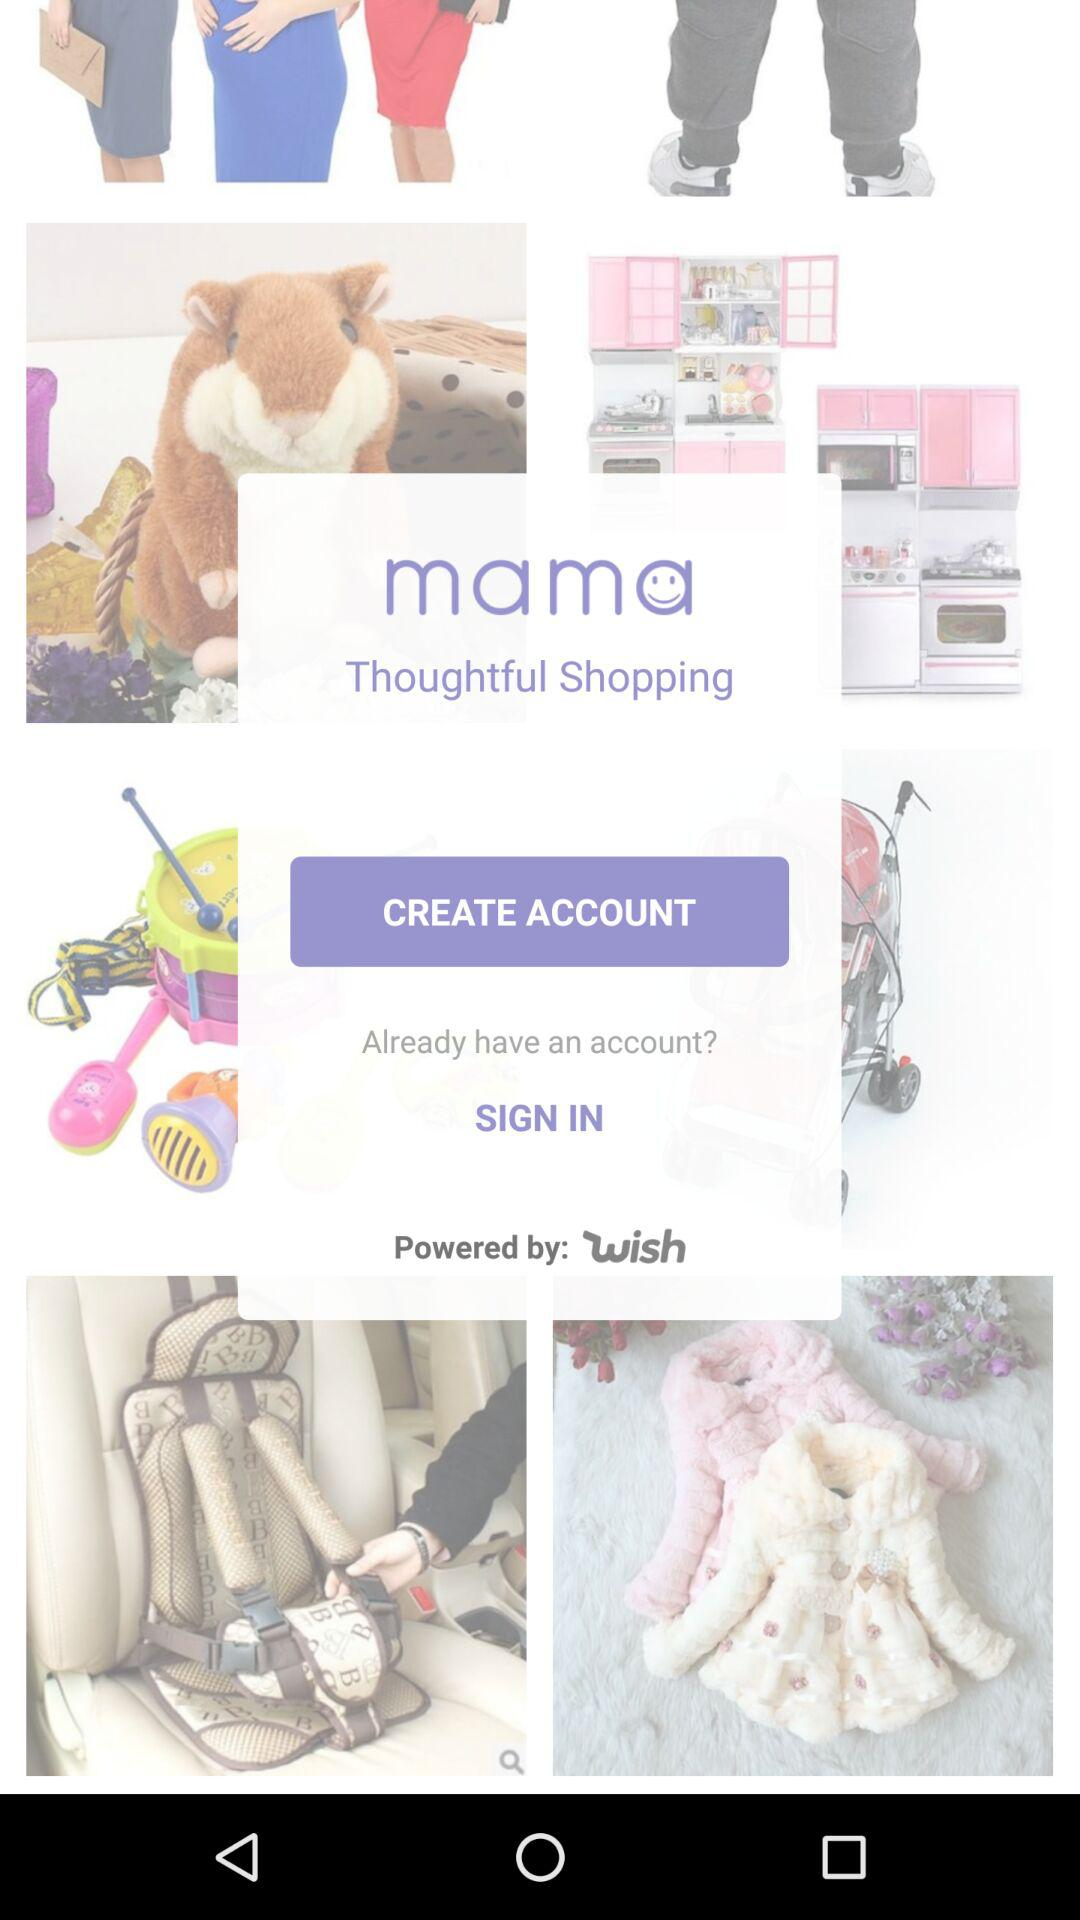By whom is "mama Thoughtful Shopping" powered? "mama Thoughtful Shopping" is powered by "Wish". 